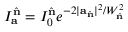Convert formula to latex. <formula><loc_0><loc_0><loc_500><loc_500>I _ { a } ^ { \hat { n } } = I _ { 0 } ^ { \hat { n } } e ^ { - 2 | a _ { \hat { n } } | ^ { 2 } / W _ { \hat { n } } ^ { 2 } }</formula> 